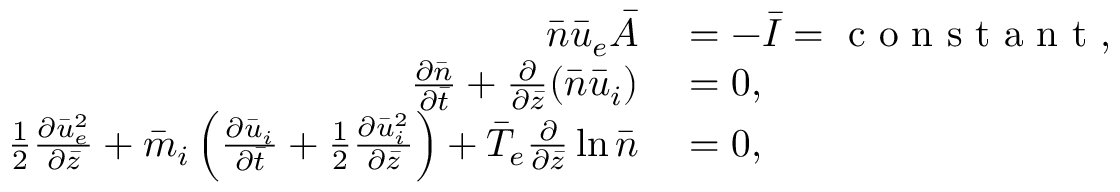<formula> <loc_0><loc_0><loc_500><loc_500>\begin{array} { r l } { \bar { n } \bar { u } _ { e } \bar { A } } & = - \bar { I } = c o n s t a n t , } \\ { \frac { \partial \bar { n } } { \partial \bar { t } } + \frac { \partial } { \partial \bar { z } } ( \bar { n } \bar { u } _ { i } ) } & = 0 , } \\ { \frac { 1 } { 2 } \frac { \partial \bar { u } _ { e } ^ { 2 } } { \partial \bar { z } } + \bar { m } _ { i } \left ( \frac { \partial \bar { u } _ { i } } { \partial \bar { t } } + \frac { 1 } { 2 } \frac { \partial \bar { u } _ { i } ^ { 2 } } { \partial \bar { z } } \right ) + \bar { T } _ { e } \frac { \partial } { \partial \bar { z } } \ln \bar { n } } & = 0 , } \end{array}</formula> 